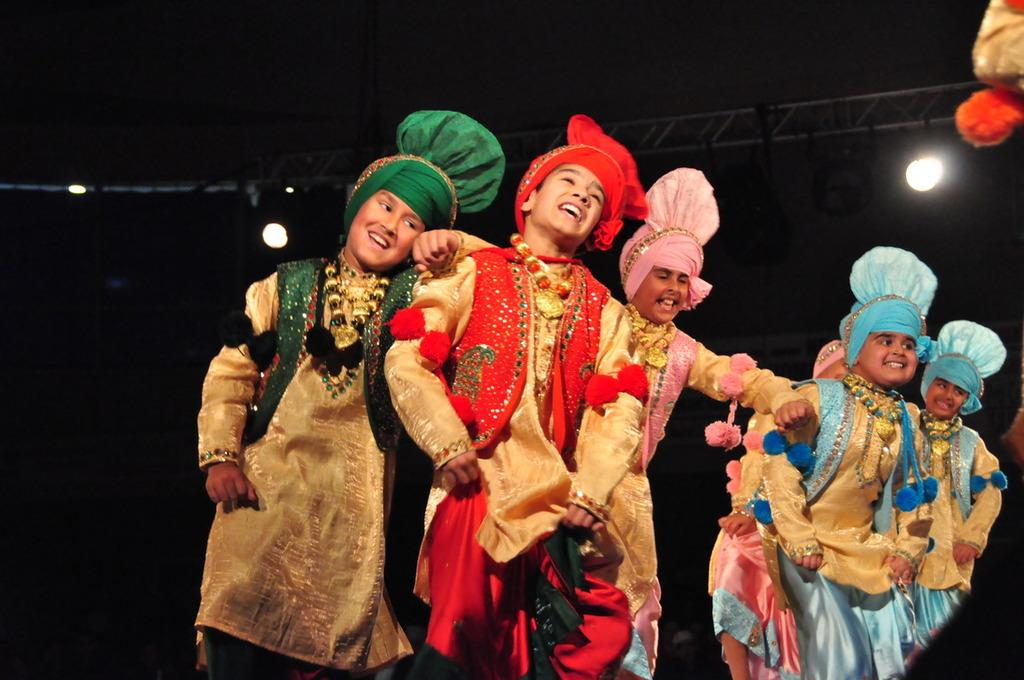What can be seen in the image? There are kids in the image. What are the kids wearing? The kids are wearing costumes. Can you describe the expressions on the kids' faces? Some kids are smiling. What can be observed about the background of the image? The background of the image has a dark view. What objects are visible in the image? There are rods and lights visible in the image. What is the weight of the beginner stage in the image? There is no stage or beginner mentioned in the image, so it's not possible to determine the weight. 